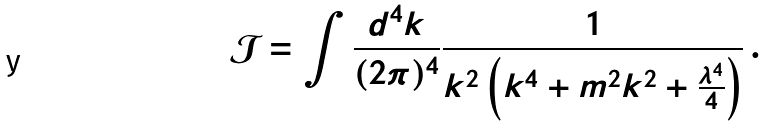<formula> <loc_0><loc_0><loc_500><loc_500>\mathcal { J } = \int \frac { d ^ { 4 } k } { ( 2 \pi ) ^ { 4 } } \frac { 1 } { k ^ { 2 } \left ( k ^ { 4 } + m ^ { 2 } k ^ { 2 } + \frac { \lambda ^ { 4 } } { 4 } \right ) } \, .</formula> 